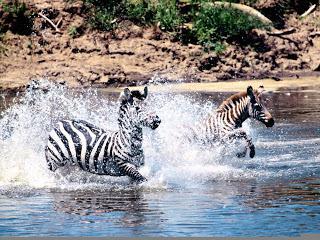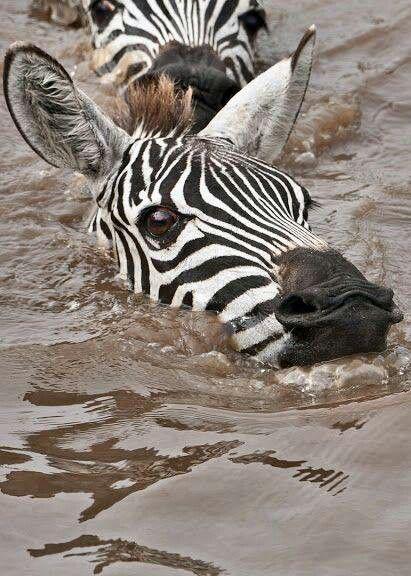The first image is the image on the left, the second image is the image on the right. Examine the images to the left and right. Is the description "The right image shows exactly two zebra heading leftward in neck-deep water, one behind the other, and the left image features a zebra with a different type of animal in the water." accurate? Answer yes or no. No. 